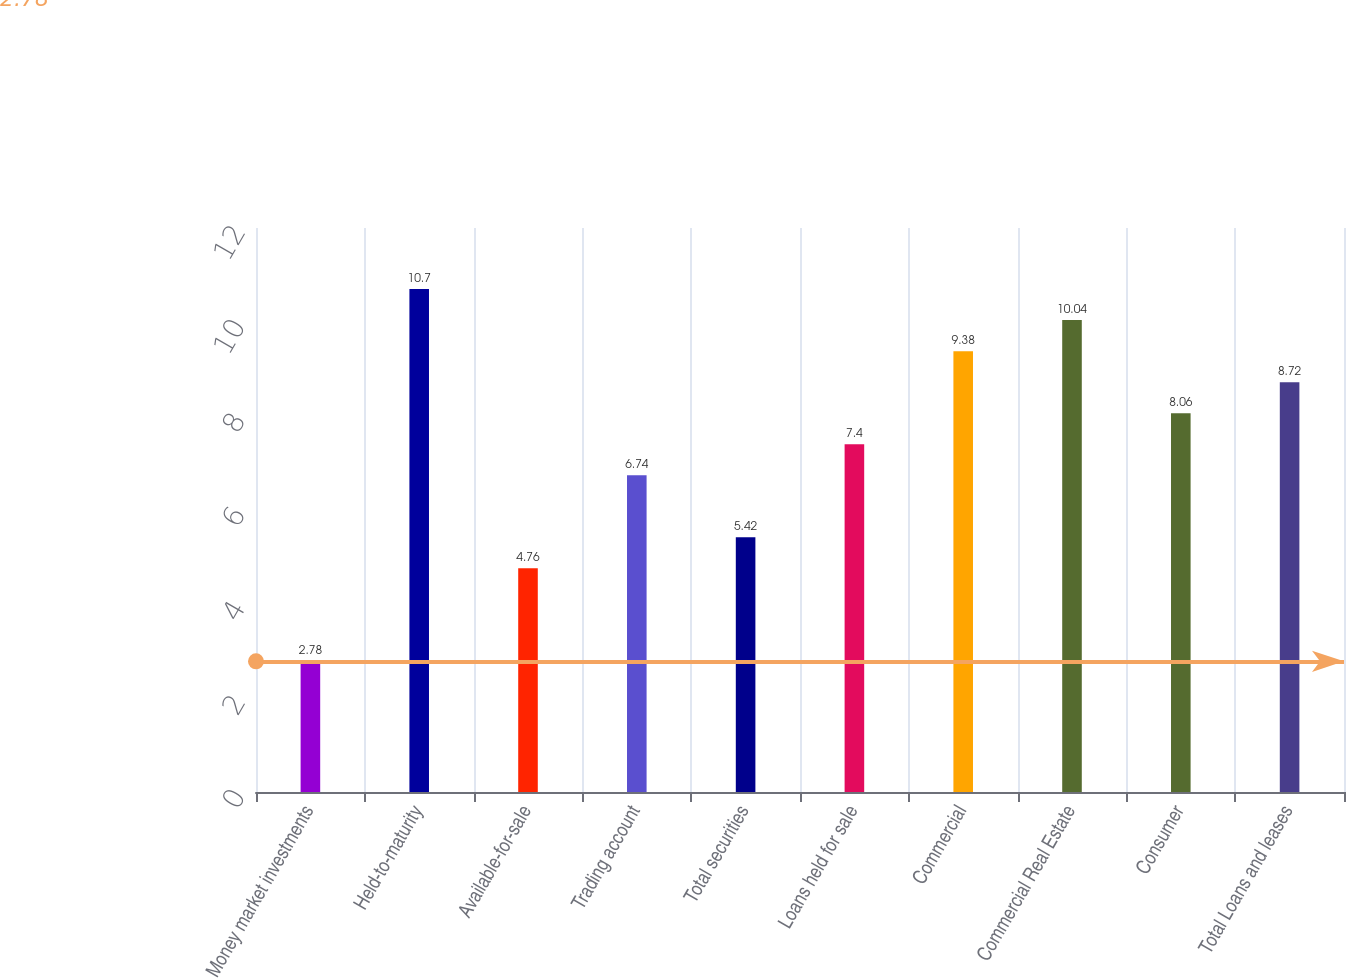<chart> <loc_0><loc_0><loc_500><loc_500><bar_chart><fcel>Money market investments<fcel>Held-to-maturity<fcel>Available-for-sale<fcel>Trading account<fcel>Total securities<fcel>Loans held for sale<fcel>Commercial<fcel>Commercial Real Estate<fcel>Consumer<fcel>Total Loans and leases<nl><fcel>2.78<fcel>10.7<fcel>4.76<fcel>6.74<fcel>5.42<fcel>7.4<fcel>9.38<fcel>10.04<fcel>8.06<fcel>8.72<nl></chart> 